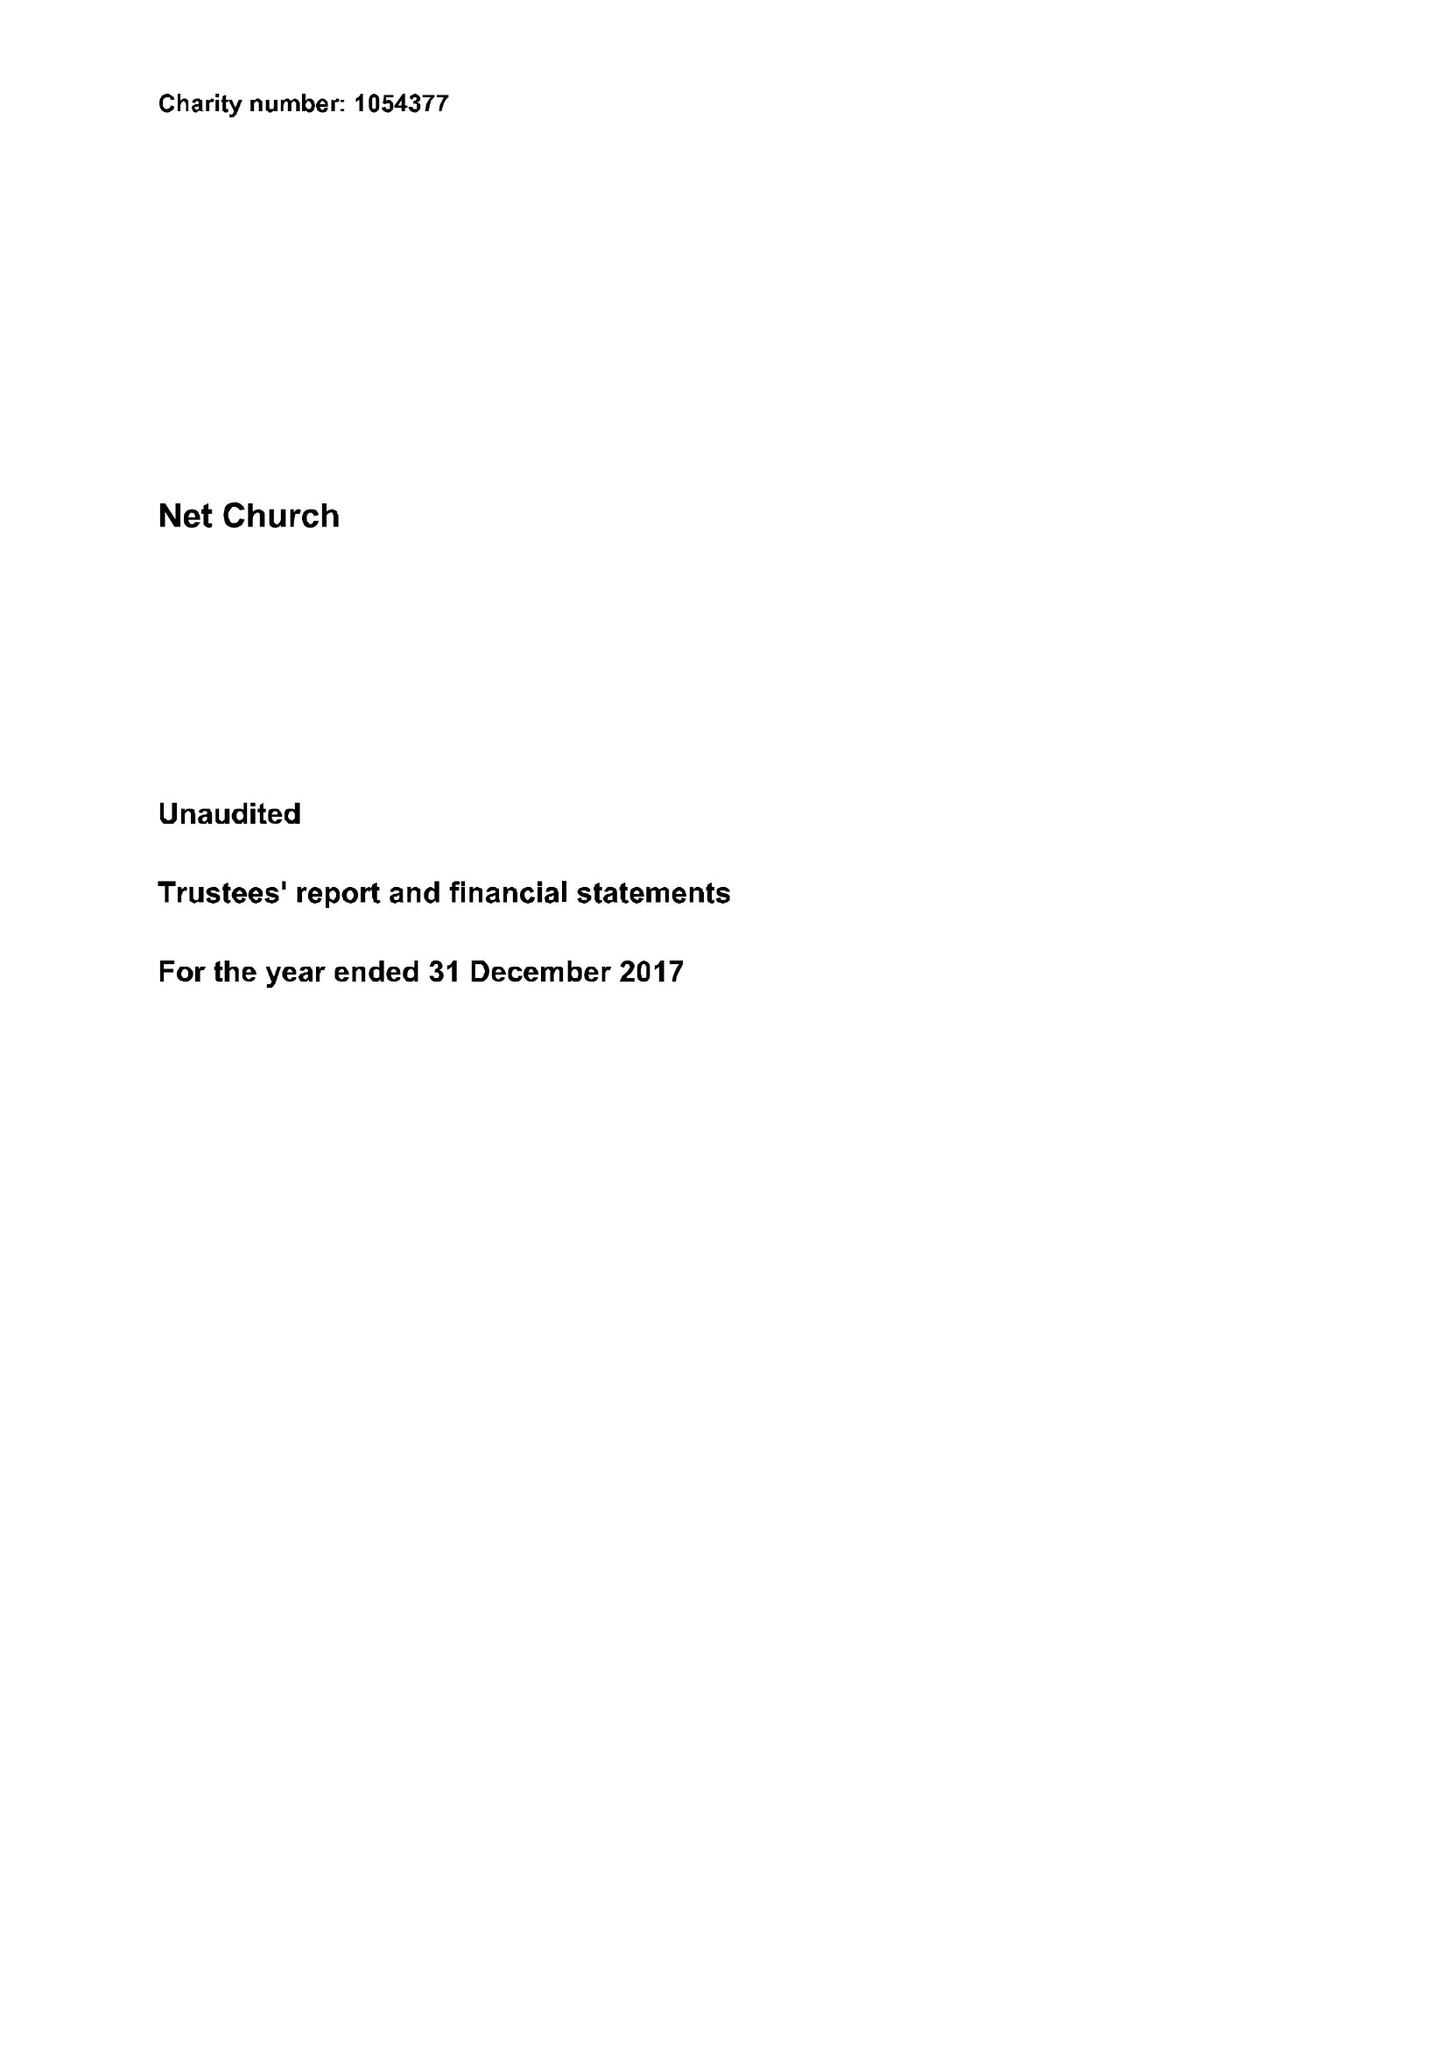What is the value for the address__street_line?
Answer the question using a single word or phrase. EAST STREET 